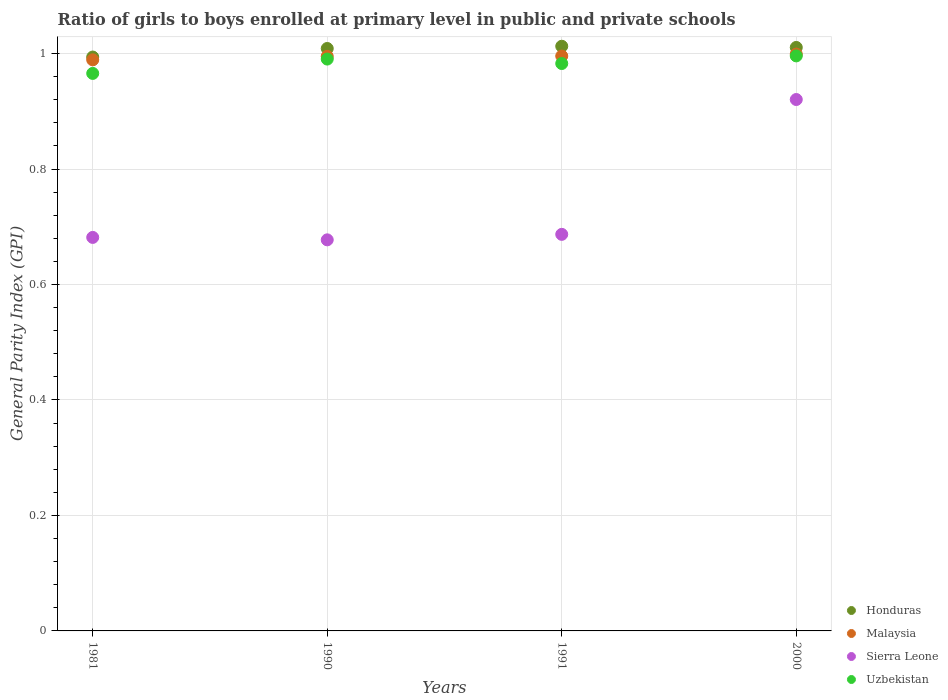Is the number of dotlines equal to the number of legend labels?
Make the answer very short. Yes. What is the general parity index in Sierra Leone in 2000?
Your answer should be very brief. 0.92. Across all years, what is the maximum general parity index in Uzbekistan?
Provide a succinct answer. 1. What is the total general parity index in Uzbekistan in the graph?
Your answer should be very brief. 3.93. What is the difference between the general parity index in Malaysia in 1991 and that in 2000?
Your answer should be very brief. -0. What is the difference between the general parity index in Malaysia in 1991 and the general parity index in Honduras in 1981?
Offer a terse response. 0. What is the average general parity index in Honduras per year?
Provide a succinct answer. 1.01. In the year 1990, what is the difference between the general parity index in Sierra Leone and general parity index in Malaysia?
Your answer should be very brief. -0.32. What is the ratio of the general parity index in Honduras in 1981 to that in 2000?
Your answer should be compact. 0.98. Is the general parity index in Malaysia in 1981 less than that in 2000?
Offer a very short reply. Yes. What is the difference between the highest and the second highest general parity index in Uzbekistan?
Ensure brevity in your answer.  0.01. What is the difference between the highest and the lowest general parity index in Uzbekistan?
Keep it short and to the point. 0.03. Is the sum of the general parity index in Uzbekistan in 1991 and 2000 greater than the maximum general parity index in Honduras across all years?
Your answer should be compact. Yes. Does the general parity index in Sierra Leone monotonically increase over the years?
Provide a short and direct response. No. Is the general parity index in Honduras strictly greater than the general parity index in Malaysia over the years?
Your response must be concise. Yes. Is the general parity index in Sierra Leone strictly less than the general parity index in Malaysia over the years?
Keep it short and to the point. Yes. How many years are there in the graph?
Provide a succinct answer. 4. What is the difference between two consecutive major ticks on the Y-axis?
Your response must be concise. 0.2. Are the values on the major ticks of Y-axis written in scientific E-notation?
Ensure brevity in your answer.  No. How are the legend labels stacked?
Ensure brevity in your answer.  Vertical. What is the title of the graph?
Ensure brevity in your answer.  Ratio of girls to boys enrolled at primary level in public and private schools. Does "Congo (Republic)" appear as one of the legend labels in the graph?
Provide a succinct answer. No. What is the label or title of the Y-axis?
Offer a terse response. General Parity Index (GPI). What is the General Parity Index (GPI) of Honduras in 1981?
Offer a very short reply. 0.99. What is the General Parity Index (GPI) in Sierra Leone in 1981?
Give a very brief answer. 0.68. What is the General Parity Index (GPI) of Uzbekistan in 1981?
Provide a succinct answer. 0.97. What is the General Parity Index (GPI) of Honduras in 1990?
Keep it short and to the point. 1.01. What is the General Parity Index (GPI) in Malaysia in 1990?
Your answer should be very brief. 1. What is the General Parity Index (GPI) in Sierra Leone in 1990?
Offer a very short reply. 0.68. What is the General Parity Index (GPI) in Uzbekistan in 1990?
Your response must be concise. 0.99. What is the General Parity Index (GPI) in Honduras in 1991?
Ensure brevity in your answer.  1.01. What is the General Parity Index (GPI) of Malaysia in 1991?
Ensure brevity in your answer.  1. What is the General Parity Index (GPI) in Sierra Leone in 1991?
Ensure brevity in your answer.  0.69. What is the General Parity Index (GPI) of Uzbekistan in 1991?
Offer a terse response. 0.98. What is the General Parity Index (GPI) in Honduras in 2000?
Ensure brevity in your answer.  1.01. What is the General Parity Index (GPI) of Malaysia in 2000?
Offer a very short reply. 1. What is the General Parity Index (GPI) of Sierra Leone in 2000?
Your answer should be very brief. 0.92. What is the General Parity Index (GPI) of Uzbekistan in 2000?
Ensure brevity in your answer.  1. Across all years, what is the maximum General Parity Index (GPI) of Honduras?
Your answer should be compact. 1.01. Across all years, what is the maximum General Parity Index (GPI) of Malaysia?
Your response must be concise. 1. Across all years, what is the maximum General Parity Index (GPI) in Sierra Leone?
Provide a succinct answer. 0.92. Across all years, what is the maximum General Parity Index (GPI) in Uzbekistan?
Ensure brevity in your answer.  1. Across all years, what is the minimum General Parity Index (GPI) of Honduras?
Your answer should be very brief. 0.99. Across all years, what is the minimum General Parity Index (GPI) in Sierra Leone?
Keep it short and to the point. 0.68. Across all years, what is the minimum General Parity Index (GPI) of Uzbekistan?
Give a very brief answer. 0.97. What is the total General Parity Index (GPI) of Honduras in the graph?
Offer a very short reply. 4.03. What is the total General Parity Index (GPI) in Malaysia in the graph?
Keep it short and to the point. 3.98. What is the total General Parity Index (GPI) of Sierra Leone in the graph?
Give a very brief answer. 2.97. What is the total General Parity Index (GPI) in Uzbekistan in the graph?
Give a very brief answer. 3.93. What is the difference between the General Parity Index (GPI) of Honduras in 1981 and that in 1990?
Your answer should be very brief. -0.01. What is the difference between the General Parity Index (GPI) of Malaysia in 1981 and that in 1990?
Provide a succinct answer. -0.01. What is the difference between the General Parity Index (GPI) of Sierra Leone in 1981 and that in 1990?
Give a very brief answer. 0. What is the difference between the General Parity Index (GPI) of Uzbekistan in 1981 and that in 1990?
Your answer should be compact. -0.02. What is the difference between the General Parity Index (GPI) in Honduras in 1981 and that in 1991?
Your answer should be compact. -0.02. What is the difference between the General Parity Index (GPI) of Malaysia in 1981 and that in 1991?
Give a very brief answer. -0.01. What is the difference between the General Parity Index (GPI) in Sierra Leone in 1981 and that in 1991?
Offer a very short reply. -0.01. What is the difference between the General Parity Index (GPI) in Uzbekistan in 1981 and that in 1991?
Ensure brevity in your answer.  -0.02. What is the difference between the General Parity Index (GPI) of Honduras in 1981 and that in 2000?
Provide a succinct answer. -0.02. What is the difference between the General Parity Index (GPI) of Malaysia in 1981 and that in 2000?
Make the answer very short. -0.01. What is the difference between the General Parity Index (GPI) in Sierra Leone in 1981 and that in 2000?
Provide a succinct answer. -0.24. What is the difference between the General Parity Index (GPI) of Uzbekistan in 1981 and that in 2000?
Provide a short and direct response. -0.03. What is the difference between the General Parity Index (GPI) of Honduras in 1990 and that in 1991?
Provide a succinct answer. -0. What is the difference between the General Parity Index (GPI) of Malaysia in 1990 and that in 1991?
Make the answer very short. -0. What is the difference between the General Parity Index (GPI) in Sierra Leone in 1990 and that in 1991?
Make the answer very short. -0.01. What is the difference between the General Parity Index (GPI) in Uzbekistan in 1990 and that in 1991?
Give a very brief answer. 0.01. What is the difference between the General Parity Index (GPI) of Honduras in 1990 and that in 2000?
Keep it short and to the point. -0. What is the difference between the General Parity Index (GPI) of Malaysia in 1990 and that in 2000?
Offer a terse response. -0. What is the difference between the General Parity Index (GPI) of Sierra Leone in 1990 and that in 2000?
Provide a succinct answer. -0.24. What is the difference between the General Parity Index (GPI) of Uzbekistan in 1990 and that in 2000?
Make the answer very short. -0.01. What is the difference between the General Parity Index (GPI) of Honduras in 1991 and that in 2000?
Your response must be concise. 0. What is the difference between the General Parity Index (GPI) of Malaysia in 1991 and that in 2000?
Your response must be concise. -0. What is the difference between the General Parity Index (GPI) in Sierra Leone in 1991 and that in 2000?
Offer a very short reply. -0.23. What is the difference between the General Parity Index (GPI) in Uzbekistan in 1991 and that in 2000?
Ensure brevity in your answer.  -0.01. What is the difference between the General Parity Index (GPI) of Honduras in 1981 and the General Parity Index (GPI) of Malaysia in 1990?
Your answer should be compact. -0. What is the difference between the General Parity Index (GPI) of Honduras in 1981 and the General Parity Index (GPI) of Sierra Leone in 1990?
Offer a terse response. 0.32. What is the difference between the General Parity Index (GPI) in Honduras in 1981 and the General Parity Index (GPI) in Uzbekistan in 1990?
Offer a terse response. 0. What is the difference between the General Parity Index (GPI) in Malaysia in 1981 and the General Parity Index (GPI) in Sierra Leone in 1990?
Your response must be concise. 0.31. What is the difference between the General Parity Index (GPI) of Malaysia in 1981 and the General Parity Index (GPI) of Uzbekistan in 1990?
Your answer should be compact. -0. What is the difference between the General Parity Index (GPI) of Sierra Leone in 1981 and the General Parity Index (GPI) of Uzbekistan in 1990?
Your answer should be compact. -0.31. What is the difference between the General Parity Index (GPI) in Honduras in 1981 and the General Parity Index (GPI) in Malaysia in 1991?
Provide a short and direct response. -0. What is the difference between the General Parity Index (GPI) in Honduras in 1981 and the General Parity Index (GPI) in Sierra Leone in 1991?
Make the answer very short. 0.31. What is the difference between the General Parity Index (GPI) in Honduras in 1981 and the General Parity Index (GPI) in Uzbekistan in 1991?
Provide a short and direct response. 0.01. What is the difference between the General Parity Index (GPI) of Malaysia in 1981 and the General Parity Index (GPI) of Sierra Leone in 1991?
Your response must be concise. 0.3. What is the difference between the General Parity Index (GPI) of Malaysia in 1981 and the General Parity Index (GPI) of Uzbekistan in 1991?
Your response must be concise. 0.01. What is the difference between the General Parity Index (GPI) of Sierra Leone in 1981 and the General Parity Index (GPI) of Uzbekistan in 1991?
Your answer should be very brief. -0.3. What is the difference between the General Parity Index (GPI) of Honduras in 1981 and the General Parity Index (GPI) of Malaysia in 2000?
Your response must be concise. -0.01. What is the difference between the General Parity Index (GPI) of Honduras in 1981 and the General Parity Index (GPI) of Sierra Leone in 2000?
Keep it short and to the point. 0.07. What is the difference between the General Parity Index (GPI) in Honduras in 1981 and the General Parity Index (GPI) in Uzbekistan in 2000?
Offer a terse response. -0. What is the difference between the General Parity Index (GPI) in Malaysia in 1981 and the General Parity Index (GPI) in Sierra Leone in 2000?
Provide a succinct answer. 0.07. What is the difference between the General Parity Index (GPI) in Malaysia in 1981 and the General Parity Index (GPI) in Uzbekistan in 2000?
Make the answer very short. -0.01. What is the difference between the General Parity Index (GPI) of Sierra Leone in 1981 and the General Parity Index (GPI) of Uzbekistan in 2000?
Your answer should be compact. -0.31. What is the difference between the General Parity Index (GPI) of Honduras in 1990 and the General Parity Index (GPI) of Malaysia in 1991?
Keep it short and to the point. 0.01. What is the difference between the General Parity Index (GPI) in Honduras in 1990 and the General Parity Index (GPI) in Sierra Leone in 1991?
Your response must be concise. 0.32. What is the difference between the General Parity Index (GPI) in Honduras in 1990 and the General Parity Index (GPI) in Uzbekistan in 1991?
Ensure brevity in your answer.  0.03. What is the difference between the General Parity Index (GPI) of Malaysia in 1990 and the General Parity Index (GPI) of Sierra Leone in 1991?
Ensure brevity in your answer.  0.31. What is the difference between the General Parity Index (GPI) in Malaysia in 1990 and the General Parity Index (GPI) in Uzbekistan in 1991?
Give a very brief answer. 0.01. What is the difference between the General Parity Index (GPI) of Sierra Leone in 1990 and the General Parity Index (GPI) of Uzbekistan in 1991?
Make the answer very short. -0.31. What is the difference between the General Parity Index (GPI) in Honduras in 1990 and the General Parity Index (GPI) in Malaysia in 2000?
Your answer should be very brief. 0.01. What is the difference between the General Parity Index (GPI) of Honduras in 1990 and the General Parity Index (GPI) of Sierra Leone in 2000?
Your response must be concise. 0.09. What is the difference between the General Parity Index (GPI) of Honduras in 1990 and the General Parity Index (GPI) of Uzbekistan in 2000?
Make the answer very short. 0.01. What is the difference between the General Parity Index (GPI) of Malaysia in 1990 and the General Parity Index (GPI) of Sierra Leone in 2000?
Your answer should be very brief. 0.07. What is the difference between the General Parity Index (GPI) of Malaysia in 1990 and the General Parity Index (GPI) of Uzbekistan in 2000?
Offer a terse response. -0. What is the difference between the General Parity Index (GPI) of Sierra Leone in 1990 and the General Parity Index (GPI) of Uzbekistan in 2000?
Your response must be concise. -0.32. What is the difference between the General Parity Index (GPI) of Honduras in 1991 and the General Parity Index (GPI) of Malaysia in 2000?
Ensure brevity in your answer.  0.01. What is the difference between the General Parity Index (GPI) in Honduras in 1991 and the General Parity Index (GPI) in Sierra Leone in 2000?
Keep it short and to the point. 0.09. What is the difference between the General Parity Index (GPI) in Honduras in 1991 and the General Parity Index (GPI) in Uzbekistan in 2000?
Provide a short and direct response. 0.02. What is the difference between the General Parity Index (GPI) in Malaysia in 1991 and the General Parity Index (GPI) in Sierra Leone in 2000?
Ensure brevity in your answer.  0.08. What is the difference between the General Parity Index (GPI) in Malaysia in 1991 and the General Parity Index (GPI) in Uzbekistan in 2000?
Your response must be concise. -0. What is the difference between the General Parity Index (GPI) in Sierra Leone in 1991 and the General Parity Index (GPI) in Uzbekistan in 2000?
Ensure brevity in your answer.  -0.31. What is the average General Parity Index (GPI) of Honduras per year?
Give a very brief answer. 1.01. What is the average General Parity Index (GPI) in Sierra Leone per year?
Offer a very short reply. 0.74. What is the average General Parity Index (GPI) of Uzbekistan per year?
Provide a succinct answer. 0.98. In the year 1981, what is the difference between the General Parity Index (GPI) in Honduras and General Parity Index (GPI) in Malaysia?
Your answer should be very brief. 0. In the year 1981, what is the difference between the General Parity Index (GPI) of Honduras and General Parity Index (GPI) of Sierra Leone?
Your answer should be very brief. 0.31. In the year 1981, what is the difference between the General Parity Index (GPI) of Honduras and General Parity Index (GPI) of Uzbekistan?
Your answer should be compact. 0.03. In the year 1981, what is the difference between the General Parity Index (GPI) in Malaysia and General Parity Index (GPI) in Sierra Leone?
Provide a short and direct response. 0.31. In the year 1981, what is the difference between the General Parity Index (GPI) of Malaysia and General Parity Index (GPI) of Uzbekistan?
Make the answer very short. 0.02. In the year 1981, what is the difference between the General Parity Index (GPI) in Sierra Leone and General Parity Index (GPI) in Uzbekistan?
Give a very brief answer. -0.28. In the year 1990, what is the difference between the General Parity Index (GPI) of Honduras and General Parity Index (GPI) of Malaysia?
Provide a succinct answer. 0.01. In the year 1990, what is the difference between the General Parity Index (GPI) in Honduras and General Parity Index (GPI) in Sierra Leone?
Provide a short and direct response. 0.33. In the year 1990, what is the difference between the General Parity Index (GPI) in Honduras and General Parity Index (GPI) in Uzbekistan?
Offer a terse response. 0.02. In the year 1990, what is the difference between the General Parity Index (GPI) in Malaysia and General Parity Index (GPI) in Sierra Leone?
Ensure brevity in your answer.  0.32. In the year 1990, what is the difference between the General Parity Index (GPI) in Malaysia and General Parity Index (GPI) in Uzbekistan?
Your answer should be compact. 0. In the year 1990, what is the difference between the General Parity Index (GPI) of Sierra Leone and General Parity Index (GPI) of Uzbekistan?
Provide a succinct answer. -0.31. In the year 1991, what is the difference between the General Parity Index (GPI) of Honduras and General Parity Index (GPI) of Malaysia?
Your answer should be compact. 0.02. In the year 1991, what is the difference between the General Parity Index (GPI) of Honduras and General Parity Index (GPI) of Sierra Leone?
Your response must be concise. 0.33. In the year 1991, what is the difference between the General Parity Index (GPI) in Honduras and General Parity Index (GPI) in Uzbekistan?
Make the answer very short. 0.03. In the year 1991, what is the difference between the General Parity Index (GPI) of Malaysia and General Parity Index (GPI) of Sierra Leone?
Offer a very short reply. 0.31. In the year 1991, what is the difference between the General Parity Index (GPI) of Malaysia and General Parity Index (GPI) of Uzbekistan?
Your answer should be compact. 0.01. In the year 1991, what is the difference between the General Parity Index (GPI) in Sierra Leone and General Parity Index (GPI) in Uzbekistan?
Your answer should be compact. -0.3. In the year 2000, what is the difference between the General Parity Index (GPI) of Honduras and General Parity Index (GPI) of Malaysia?
Your answer should be very brief. 0.01. In the year 2000, what is the difference between the General Parity Index (GPI) of Honduras and General Parity Index (GPI) of Sierra Leone?
Your response must be concise. 0.09. In the year 2000, what is the difference between the General Parity Index (GPI) in Honduras and General Parity Index (GPI) in Uzbekistan?
Your answer should be very brief. 0.01. In the year 2000, what is the difference between the General Parity Index (GPI) in Malaysia and General Parity Index (GPI) in Sierra Leone?
Keep it short and to the point. 0.08. In the year 2000, what is the difference between the General Parity Index (GPI) of Malaysia and General Parity Index (GPI) of Uzbekistan?
Ensure brevity in your answer.  0. In the year 2000, what is the difference between the General Parity Index (GPI) in Sierra Leone and General Parity Index (GPI) in Uzbekistan?
Your answer should be compact. -0.08. What is the ratio of the General Parity Index (GPI) of Malaysia in 1981 to that in 1990?
Provide a succinct answer. 0.99. What is the ratio of the General Parity Index (GPI) in Uzbekistan in 1981 to that in 1990?
Offer a very short reply. 0.97. What is the ratio of the General Parity Index (GPI) in Honduras in 1981 to that in 1991?
Your response must be concise. 0.98. What is the ratio of the General Parity Index (GPI) in Malaysia in 1981 to that in 1991?
Your response must be concise. 0.99. What is the ratio of the General Parity Index (GPI) of Sierra Leone in 1981 to that in 1991?
Your response must be concise. 0.99. What is the ratio of the General Parity Index (GPI) in Uzbekistan in 1981 to that in 1991?
Provide a short and direct response. 0.98. What is the ratio of the General Parity Index (GPI) of Honduras in 1981 to that in 2000?
Offer a terse response. 0.98. What is the ratio of the General Parity Index (GPI) in Sierra Leone in 1981 to that in 2000?
Provide a short and direct response. 0.74. What is the ratio of the General Parity Index (GPI) of Uzbekistan in 1981 to that in 2000?
Offer a terse response. 0.97. What is the ratio of the General Parity Index (GPI) of Malaysia in 1990 to that in 1991?
Give a very brief answer. 1. What is the ratio of the General Parity Index (GPI) of Sierra Leone in 1990 to that in 1991?
Offer a very short reply. 0.99. What is the ratio of the General Parity Index (GPI) of Uzbekistan in 1990 to that in 1991?
Ensure brevity in your answer.  1.01. What is the ratio of the General Parity Index (GPI) of Honduras in 1990 to that in 2000?
Make the answer very short. 1. What is the ratio of the General Parity Index (GPI) in Sierra Leone in 1990 to that in 2000?
Give a very brief answer. 0.74. What is the ratio of the General Parity Index (GPI) of Uzbekistan in 1990 to that in 2000?
Ensure brevity in your answer.  0.99. What is the ratio of the General Parity Index (GPI) in Malaysia in 1991 to that in 2000?
Give a very brief answer. 1. What is the ratio of the General Parity Index (GPI) in Sierra Leone in 1991 to that in 2000?
Make the answer very short. 0.75. What is the ratio of the General Parity Index (GPI) of Uzbekistan in 1991 to that in 2000?
Offer a very short reply. 0.99. What is the difference between the highest and the second highest General Parity Index (GPI) in Honduras?
Offer a terse response. 0. What is the difference between the highest and the second highest General Parity Index (GPI) of Malaysia?
Your answer should be compact. 0. What is the difference between the highest and the second highest General Parity Index (GPI) in Sierra Leone?
Your answer should be compact. 0.23. What is the difference between the highest and the second highest General Parity Index (GPI) in Uzbekistan?
Ensure brevity in your answer.  0.01. What is the difference between the highest and the lowest General Parity Index (GPI) of Honduras?
Your response must be concise. 0.02. What is the difference between the highest and the lowest General Parity Index (GPI) of Malaysia?
Provide a short and direct response. 0.01. What is the difference between the highest and the lowest General Parity Index (GPI) in Sierra Leone?
Make the answer very short. 0.24. What is the difference between the highest and the lowest General Parity Index (GPI) of Uzbekistan?
Your answer should be compact. 0.03. 